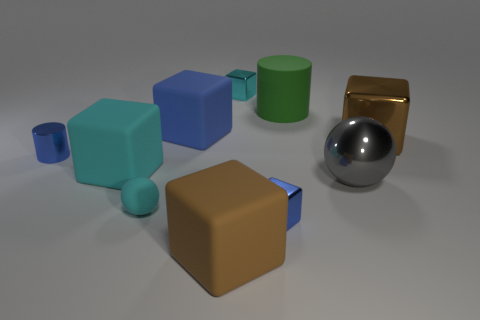There is a brown cube that is the same material as the big blue thing; what size is it?
Give a very brief answer. Large. How many matte objects are the same color as the rubber cylinder?
Keep it short and to the point. 0. Is the size of the brown object that is to the left of the gray shiny thing the same as the small rubber object?
Your answer should be very brief. No. There is a tiny block in front of the cyan metal cube; is it the same color as the tiny cylinder?
Your response must be concise. Yes. Is the material of the large green object the same as the large blue object?
Provide a succinct answer. Yes. What is the color of the tiny cube that is behind the big rubber cylinder?
Keep it short and to the point. Cyan. Is the number of small blue metal objects that are to the right of the cyan matte block greater than the number of big red blocks?
Your response must be concise. Yes. What number of other things are there of the same size as the brown shiny cube?
Your answer should be very brief. 5. There is a blue rubber block; how many cylinders are in front of it?
Provide a succinct answer. 1. Is the number of tiny blue objects that are right of the big shiny ball the same as the number of gray spheres that are right of the big blue object?
Give a very brief answer. No. 